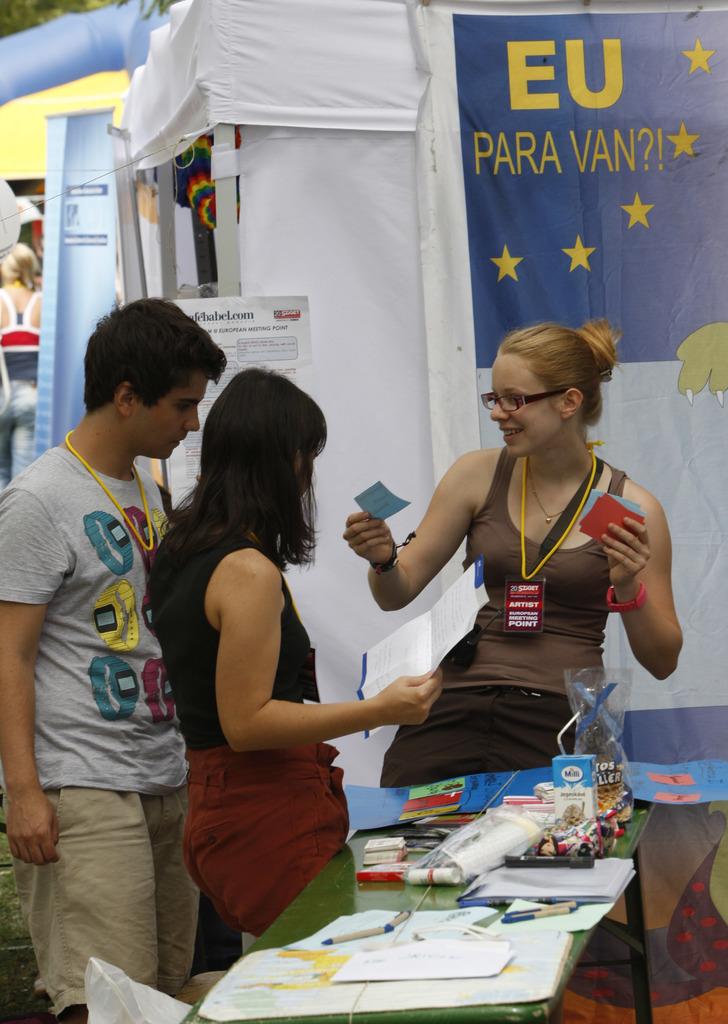What region is associated with para van?
Provide a succinct answer. Eu. 